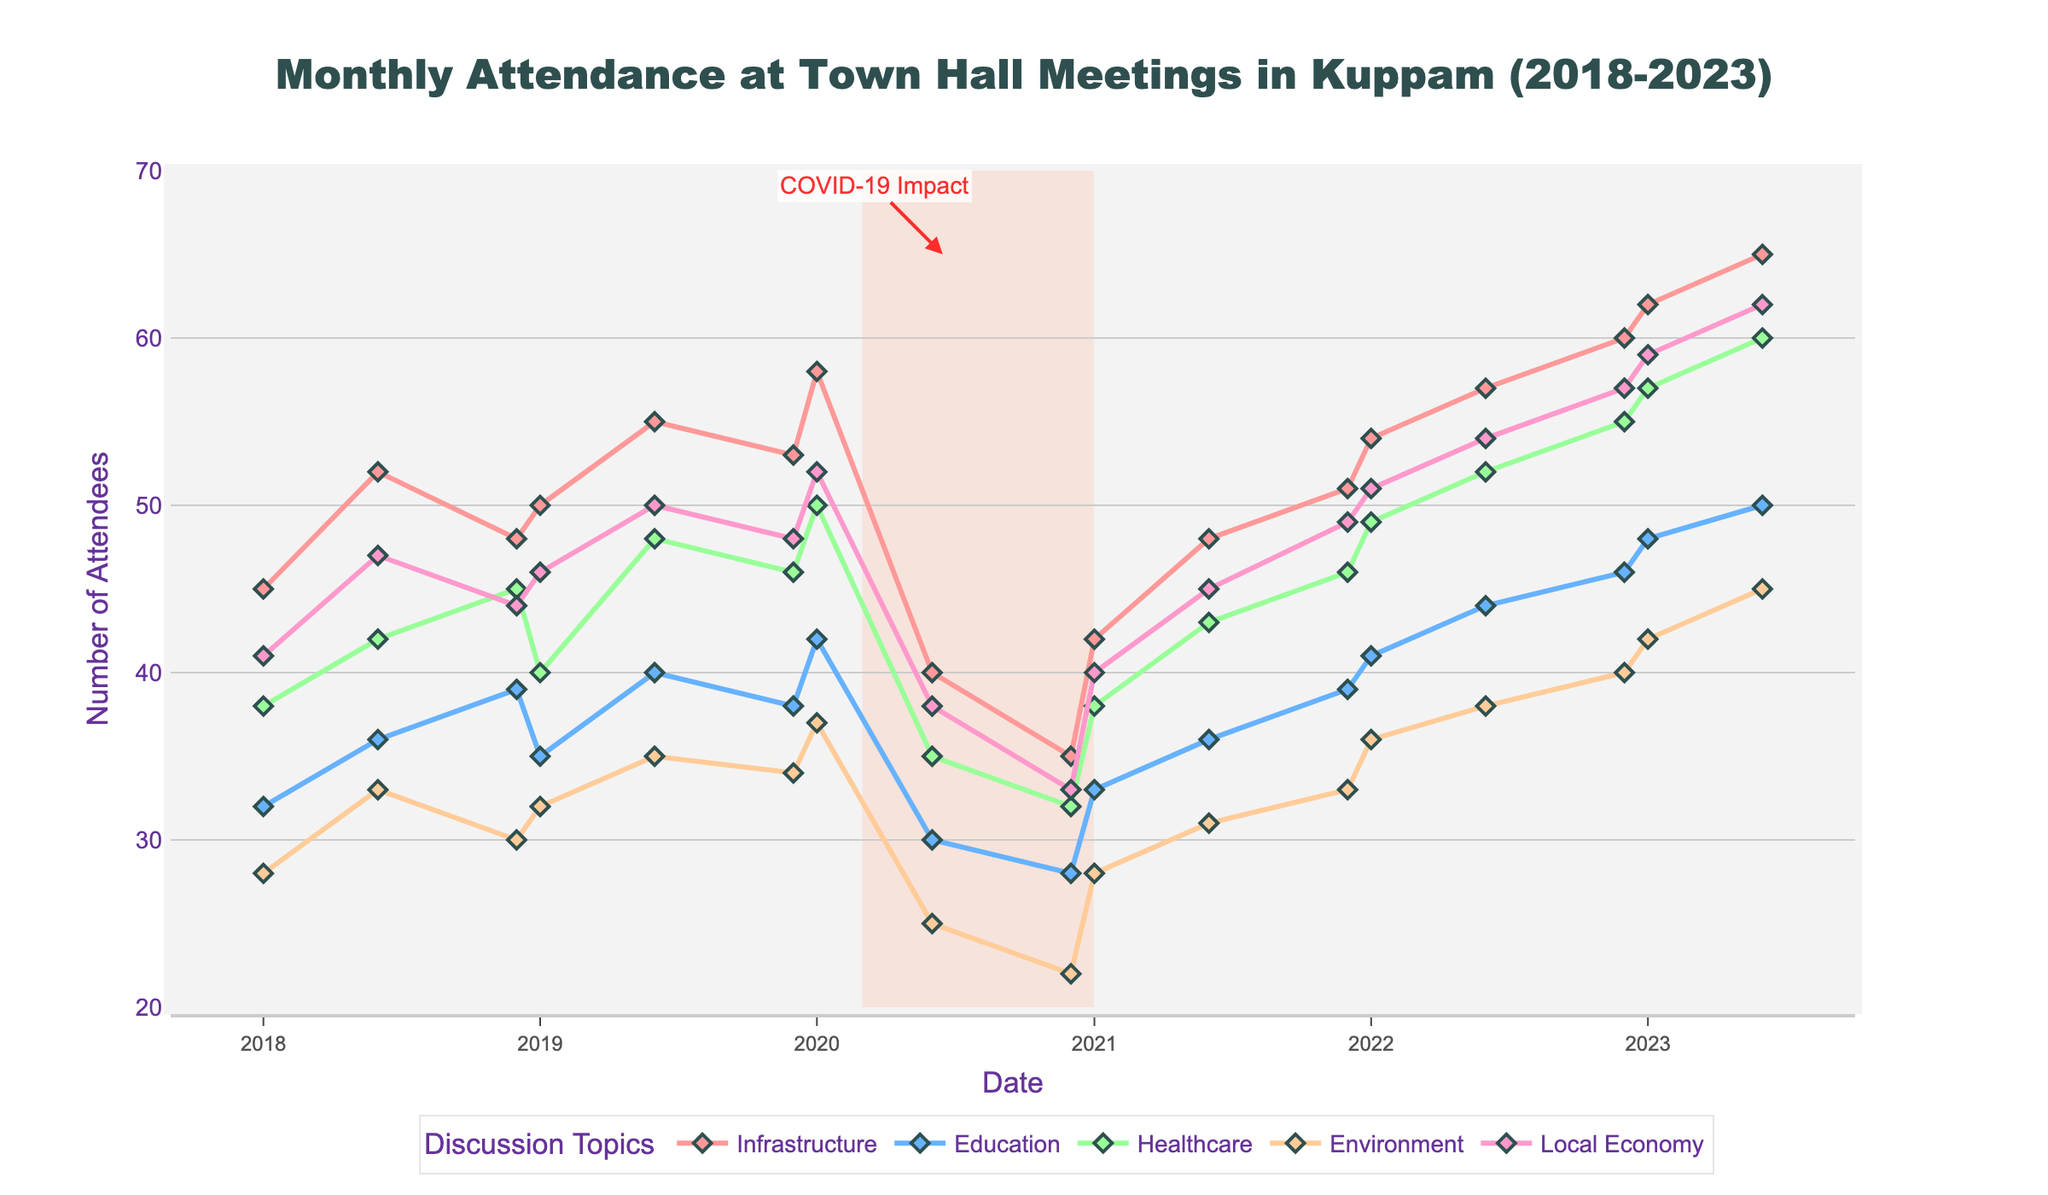What trend in attendance do you see for the discussion on Healthcare over the period of 2020 to 2021? The attendance drops from 50 in January 2020 to a low of 32 in December 2020, then increases to 49 in December 2021. This shows a decline throughout 2020 and a recovery in 2021.
Answer: Decline in 2020, recovery in 2021 Which discussion topic had the highest attendance in June 2023? By observing the points on the line chart, the Local Economy discussion notably peaks in June 2023 with an attendance of 62, surpassing the others.
Answer: Local Economy How did the attendance for Infrastructure discussions change before and after the COVID-19 impact period marked on the chart? The attendance for Infrastructure was at 58 in January 2020, dropped during the COVID-19 impact phase to 35 in December 2020, and then rebounded to 54 in January 2022, showing recovery post-pandemic.
Answer: Drop during COVID-19, then recovery Compare the attendance trends between Education and Environment discussions from 2018 to 2023. Both topics show an increase in attendance over time, but Education has a more modest and steady growth compared to the fluctuating and slightly lesser rise in Environment.
Answer: Education: steady growth, Environment: fluctuating growth What was the average attendance for town hall meetings discussing Local Economy from 2018 to 2023? Adding up the attendance numbers for each point recorded for Local Economy (41, 47, 44, 46, 50, 48, 52, 38, 33, 40, 45, 49, 51, 54, 57, 59, 62) and dividing by the number of these points (17) results in an average of approximately (856/17 =) 50.35.
Answer: About 50 Which discussion topic showed the least variation in attendance from 2018 to 2023? Examining the fluctuations in attendance for each topic, we see Healthcare has the least variation, as the attendance numbers do not deviate significantly from mid-30s to mid-50s over the given period.
Answer: Healthcare Identify the month and year when all discussion topics experienced a notable drop in attendance. During the COVID-19 mark, particularly from January 2020 (before COVID-19) to December 2020. Every line drops in the range of 25-37 attendees.
Answer: December 2020 How did the attendance for the Education discussion topic in January 2023 compare to the attendance in January 2019? The attendance for Education in January 2023 was 48, which is higher compared to the attendance in January 2019 which was 35.
Answer: Higher in January 2023 If we sum the attendance of all topics in June 2023, what is the total? Summing up the attendance for each topic in June 2023 gives us Infrastructure (65) + Education (50) + Healthcare (60) + Environment (45) + Local Economy (62) = 282.
Answer: 282 How did the attendance trend for Environmental discussions change in response to the COVID-19 impact period? Environmental discussions saw a drop from 37 in January 2020 to 22 in December 2020, then a rise to 33 in December 2021, indicating a drop during the COVID-19 impact and recovery post-pandemic.
Answer: Drop during COVID-19, recovery post-pandemic 